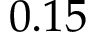<formula> <loc_0><loc_0><loc_500><loc_500>0 . 1 5</formula> 